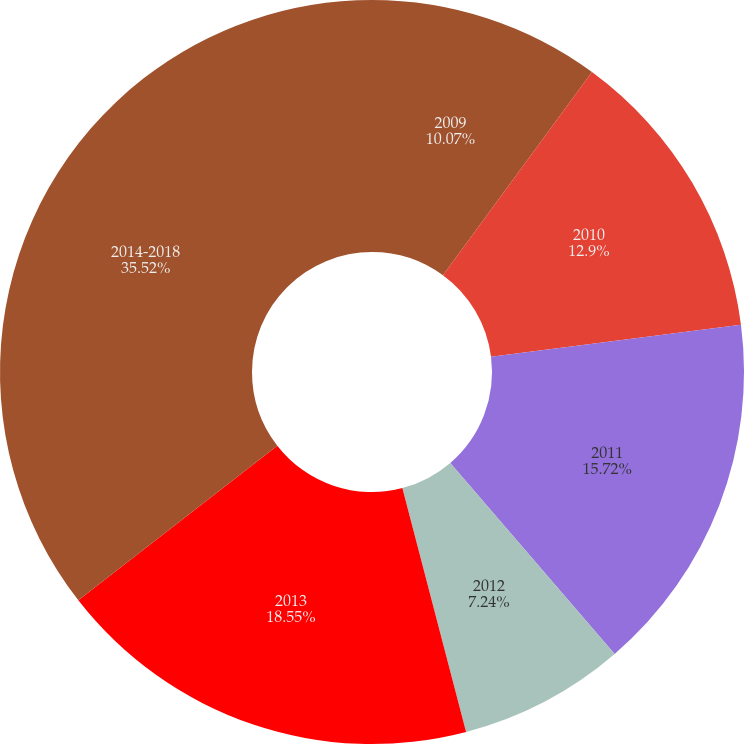Convert chart. <chart><loc_0><loc_0><loc_500><loc_500><pie_chart><fcel>2009<fcel>2010<fcel>2011<fcel>2012<fcel>2013<fcel>2014-2018<nl><fcel>10.07%<fcel>12.9%<fcel>15.72%<fcel>7.24%<fcel>18.55%<fcel>35.52%<nl></chart> 